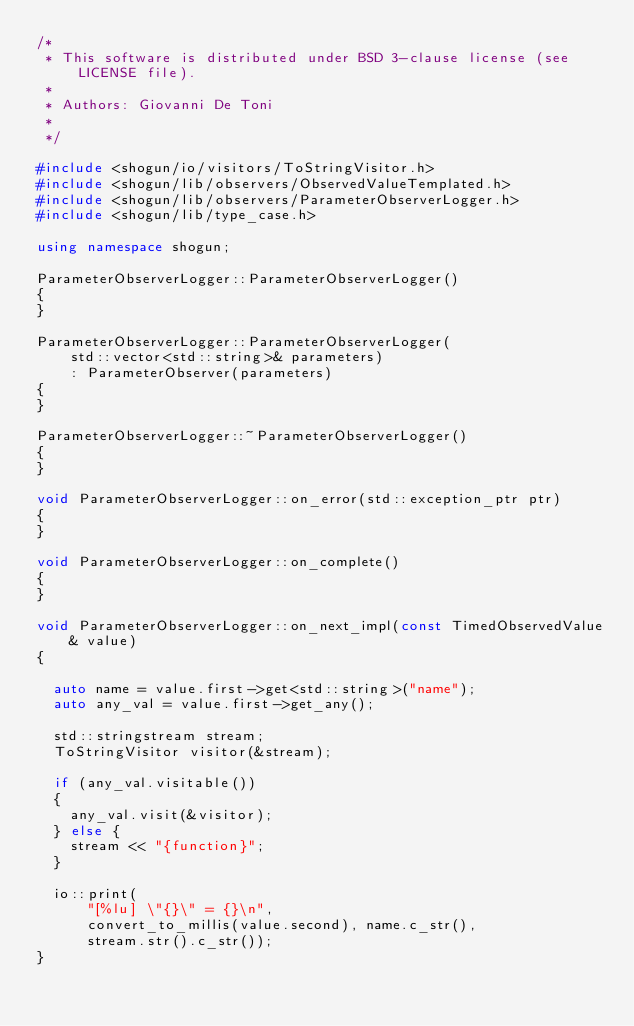Convert code to text. <code><loc_0><loc_0><loc_500><loc_500><_C++_>/*
 * This software is distributed under BSD 3-clause license (see LICENSE file).
 *
 * Authors: Giovanni De Toni
 *
 */

#include <shogun/io/visitors/ToStringVisitor.h>
#include <shogun/lib/observers/ObservedValueTemplated.h>
#include <shogun/lib/observers/ParameterObserverLogger.h>
#include <shogun/lib/type_case.h>

using namespace shogun;

ParameterObserverLogger::ParameterObserverLogger()
{
}

ParameterObserverLogger::ParameterObserverLogger(
    std::vector<std::string>& parameters)
    : ParameterObserver(parameters)
{
}

ParameterObserverLogger::~ParameterObserverLogger()
{
}

void ParameterObserverLogger::on_error(std::exception_ptr ptr)
{
}

void ParameterObserverLogger::on_complete()
{
}

void ParameterObserverLogger::on_next_impl(const TimedObservedValue& value)
{

	auto name = value.first->get<std::string>("name");
	auto any_val = value.first->get_any();

	std::stringstream stream;
	ToStringVisitor visitor(&stream);

	if (any_val.visitable())
	{
		any_val.visit(&visitor);
	} else {
		stream << "{function}";
	}

	io::print(
			"[%lu] \"{}\" = {}\n",
			convert_to_millis(value.second), name.c_str(),
			stream.str().c_str());
}
</code> 